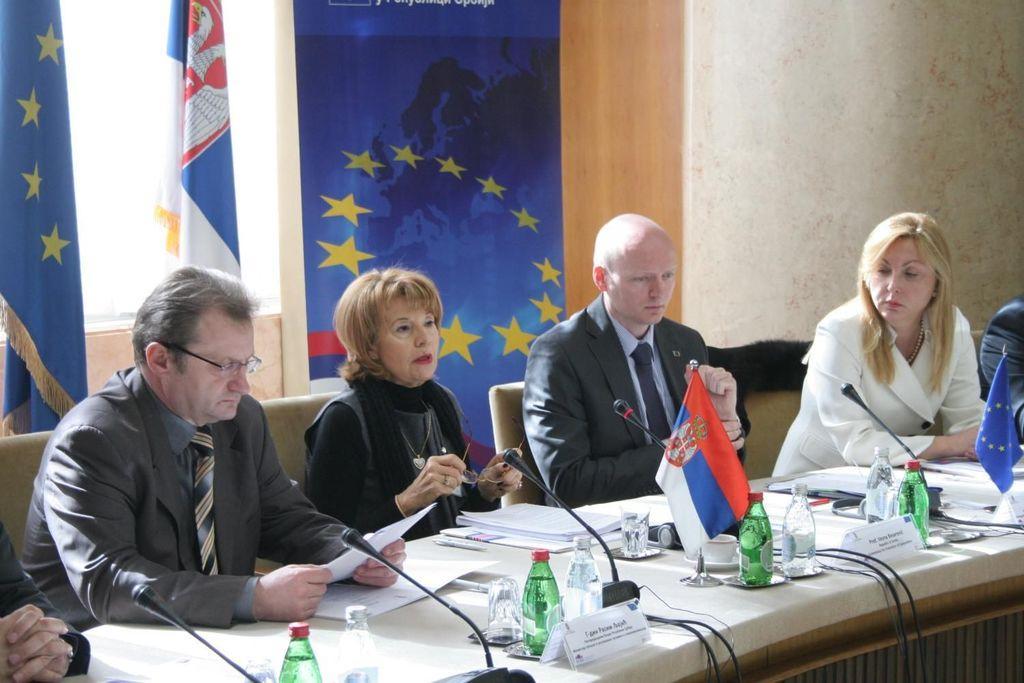Could you give a brief overview of what you see in this image? This image is clicked in a room. There is a table and chairs. On the chairs the people sitting. There are flags behind them. On the table there are mikes, bottles, glasses, papers and books. 